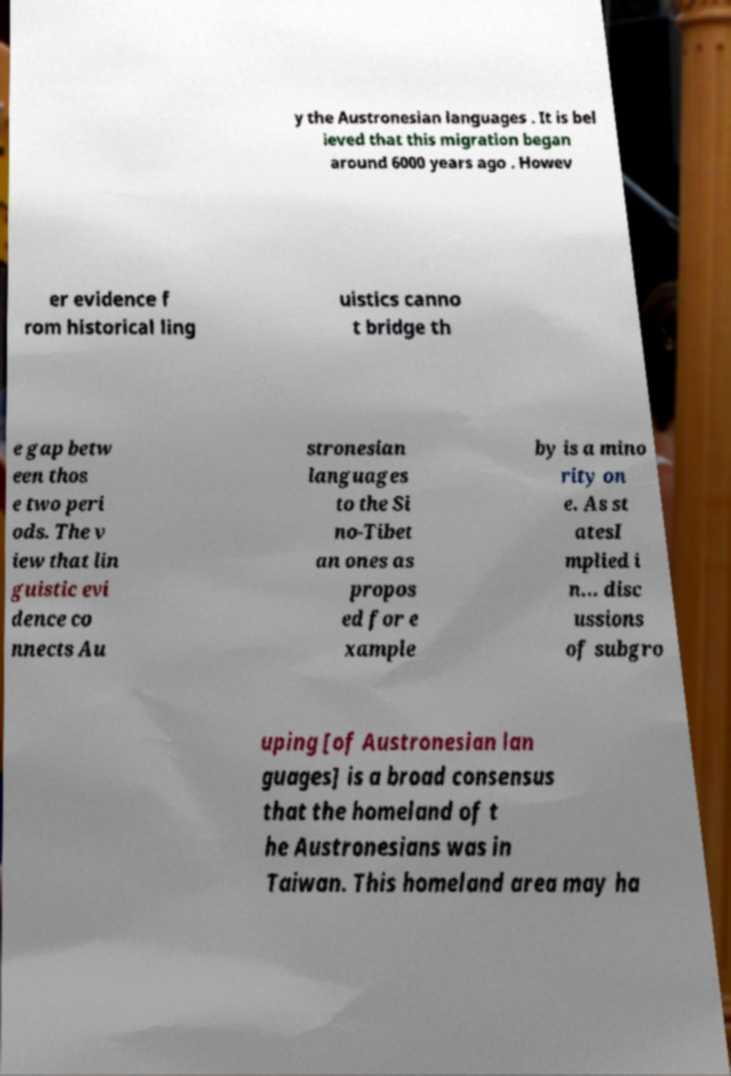I need the written content from this picture converted into text. Can you do that? y the Austronesian languages . It is bel ieved that this migration began around 6000 years ago . Howev er evidence f rom historical ling uistics canno t bridge th e gap betw een thos e two peri ods. The v iew that lin guistic evi dence co nnects Au stronesian languages to the Si no-Tibet an ones as propos ed for e xample by is a mino rity on e. As st atesI mplied i n... disc ussions of subgro uping [of Austronesian lan guages] is a broad consensus that the homeland of t he Austronesians was in Taiwan. This homeland area may ha 